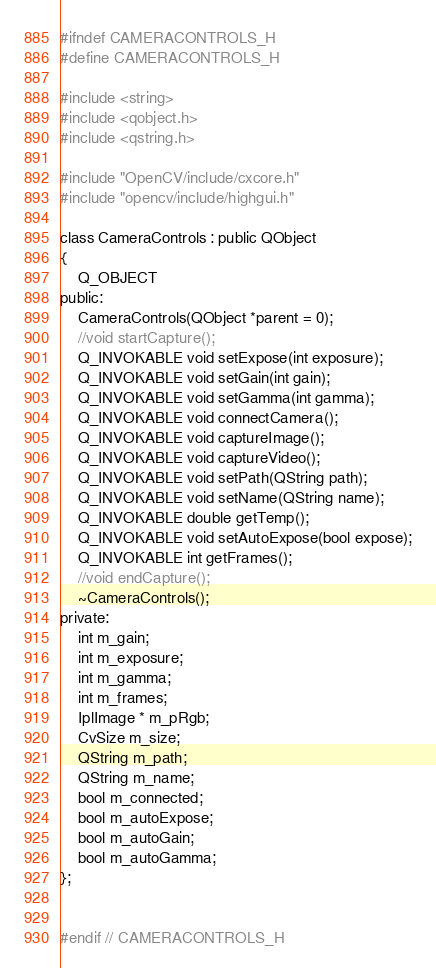<code> <loc_0><loc_0><loc_500><loc_500><_C_>#ifndef CAMERACONTROLS_H
#define CAMERACONTROLS_H

#include <string>
#include <qobject.h>
#include <qstring.h>

#include "OpenCV/include/cxcore.h"
#include "opencv/include/highgui.h"

class CameraControls : public QObject
{
    Q_OBJECT
public:
    CameraControls(QObject *parent = 0);
    //void startCapture();
    Q_INVOKABLE void setExpose(int exposure);
    Q_INVOKABLE void setGain(int gain);
    Q_INVOKABLE void setGamma(int gamma);
    Q_INVOKABLE void connectCamera();
    Q_INVOKABLE void captureImage();
    Q_INVOKABLE void captureVideo();
    Q_INVOKABLE void setPath(QString path);
    Q_INVOKABLE void setName(QString name);
    Q_INVOKABLE double getTemp();
    Q_INVOKABLE void setAutoExpose(bool expose);
    Q_INVOKABLE int getFrames();
    //void endCapture();
    ~CameraControls();
private:
    int m_gain;
    int m_exposure;
    int m_gamma;
    int m_frames;
    IplImage * m_pRgb;
    CvSize m_size;
    QString m_path;
    QString m_name;
    bool m_connected;
    bool m_autoExpose;
    bool m_autoGain;
    bool m_autoGamma;
};


#endif // CAMERACONTROLS_H
</code> 